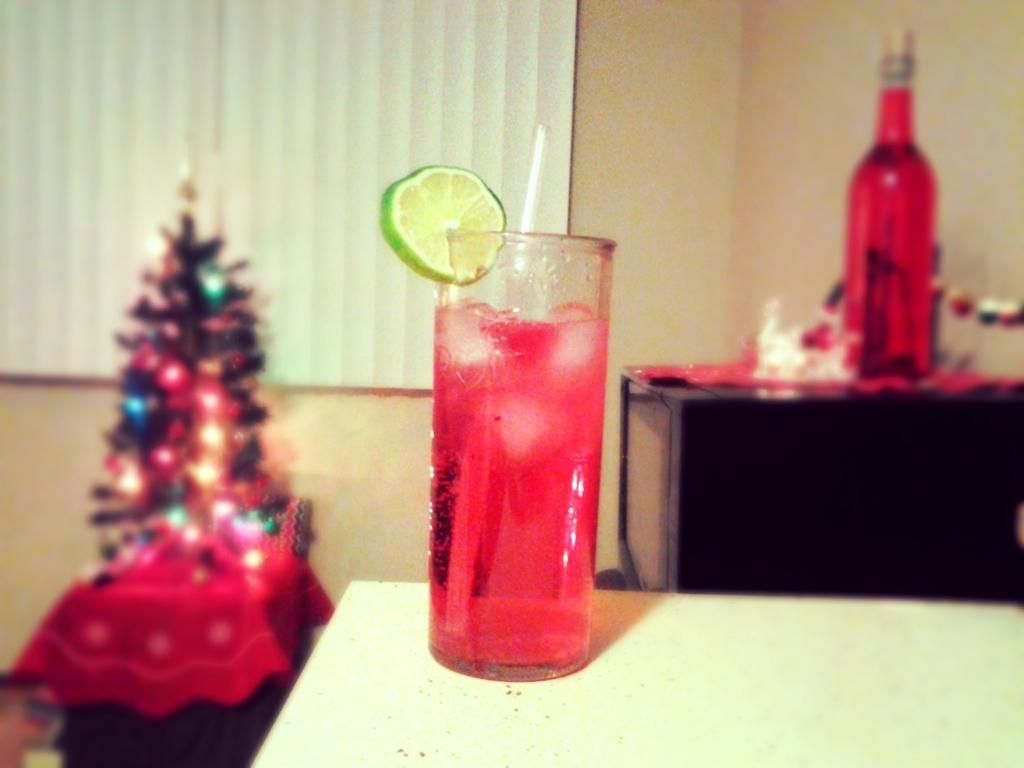Describe this image in one or two sentences. In this picture we can see a glass with ice cubes in it and lemon attached to it this is on table and in background we can see bottle, microwave oven,window with curtain, Christmas tree. 